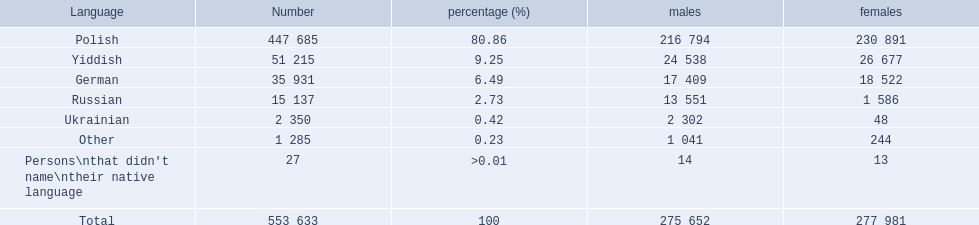How many speakers are represented in polish? 447 685. How many represented speakers are yiddish? 51 215. What is the total number of speakers? 553 633. 